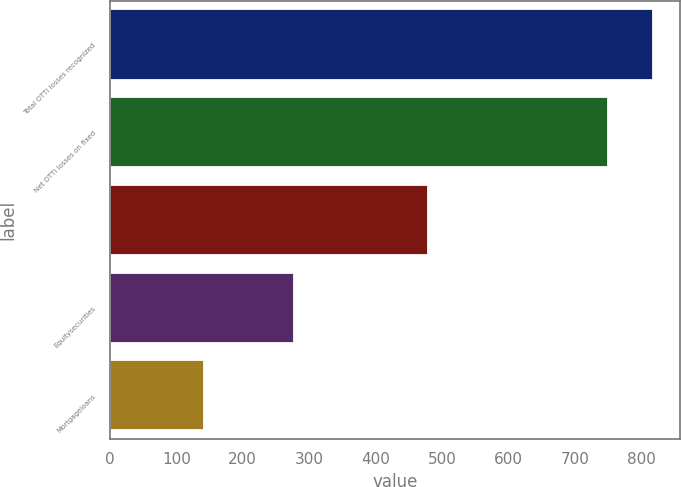<chart> <loc_0><loc_0><loc_500><loc_500><bar_chart><fcel>Total OTTI losses recognized<fcel>Net OTTI losses on fixed<fcel>Unnamed: 2<fcel>Equitysecurities<fcel>Mortgageloans<nl><fcel>817.2<fcel>749.6<fcel>479.2<fcel>276.4<fcel>141.2<nl></chart> 